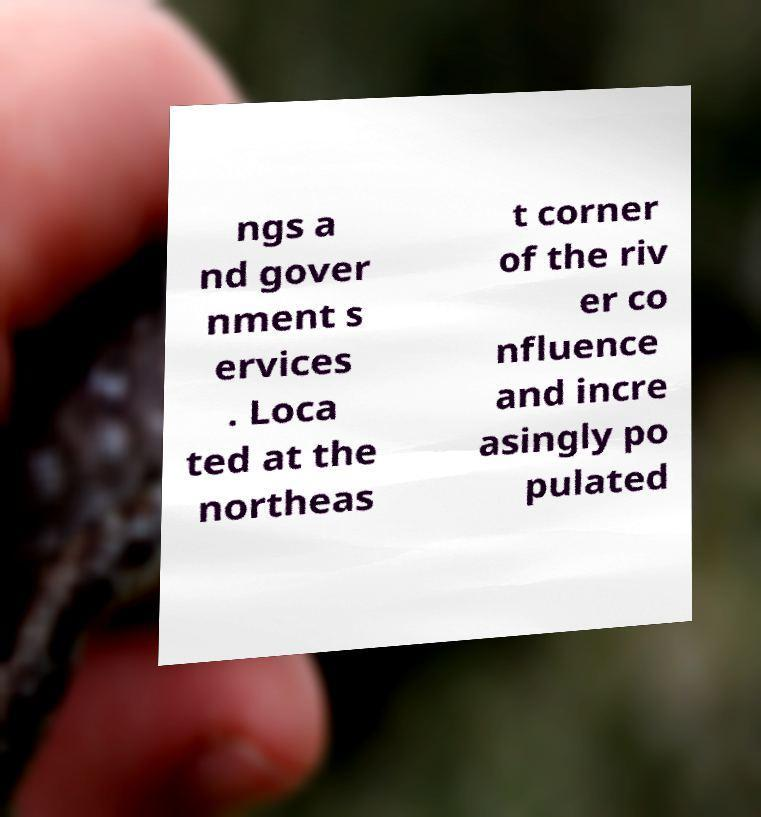I need the written content from this picture converted into text. Can you do that? ngs a nd gover nment s ervices . Loca ted at the northeas t corner of the riv er co nfluence and incre asingly po pulated 